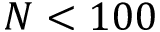<formula> <loc_0><loc_0><loc_500><loc_500>N < 1 0 0</formula> 